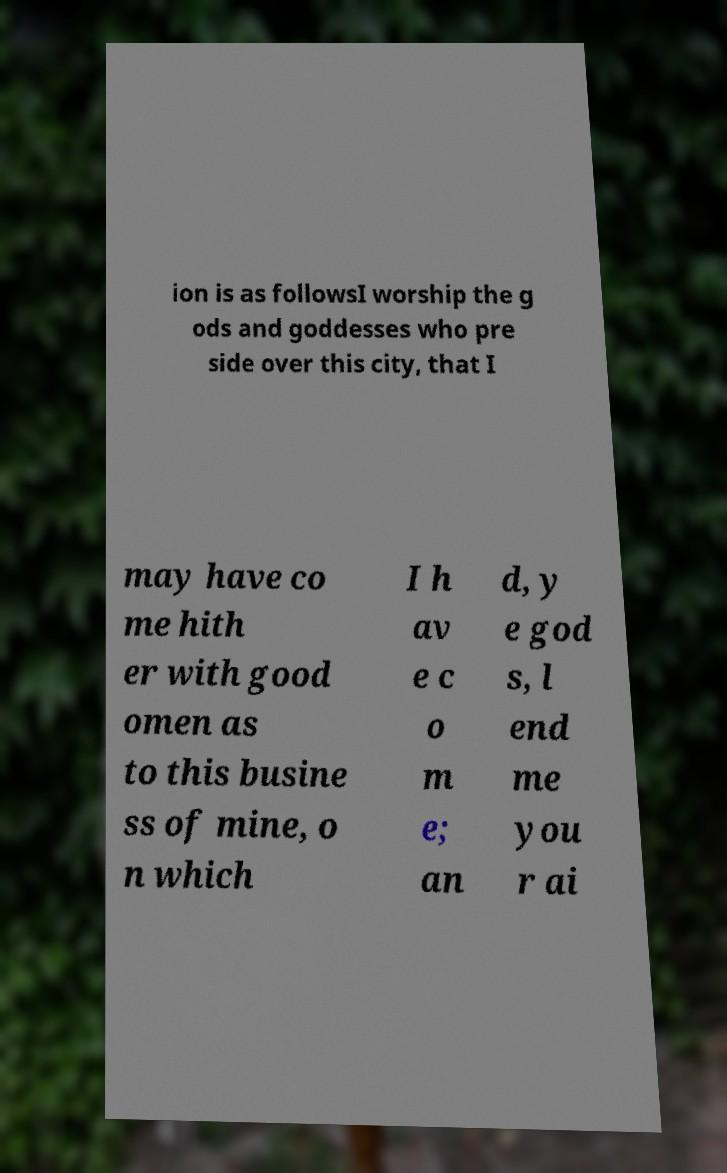For documentation purposes, I need the text within this image transcribed. Could you provide that? ion is as followsI worship the g ods and goddesses who pre side over this city, that I may have co me hith er with good omen as to this busine ss of mine, o n which I h av e c o m e; an d, y e god s, l end me you r ai 